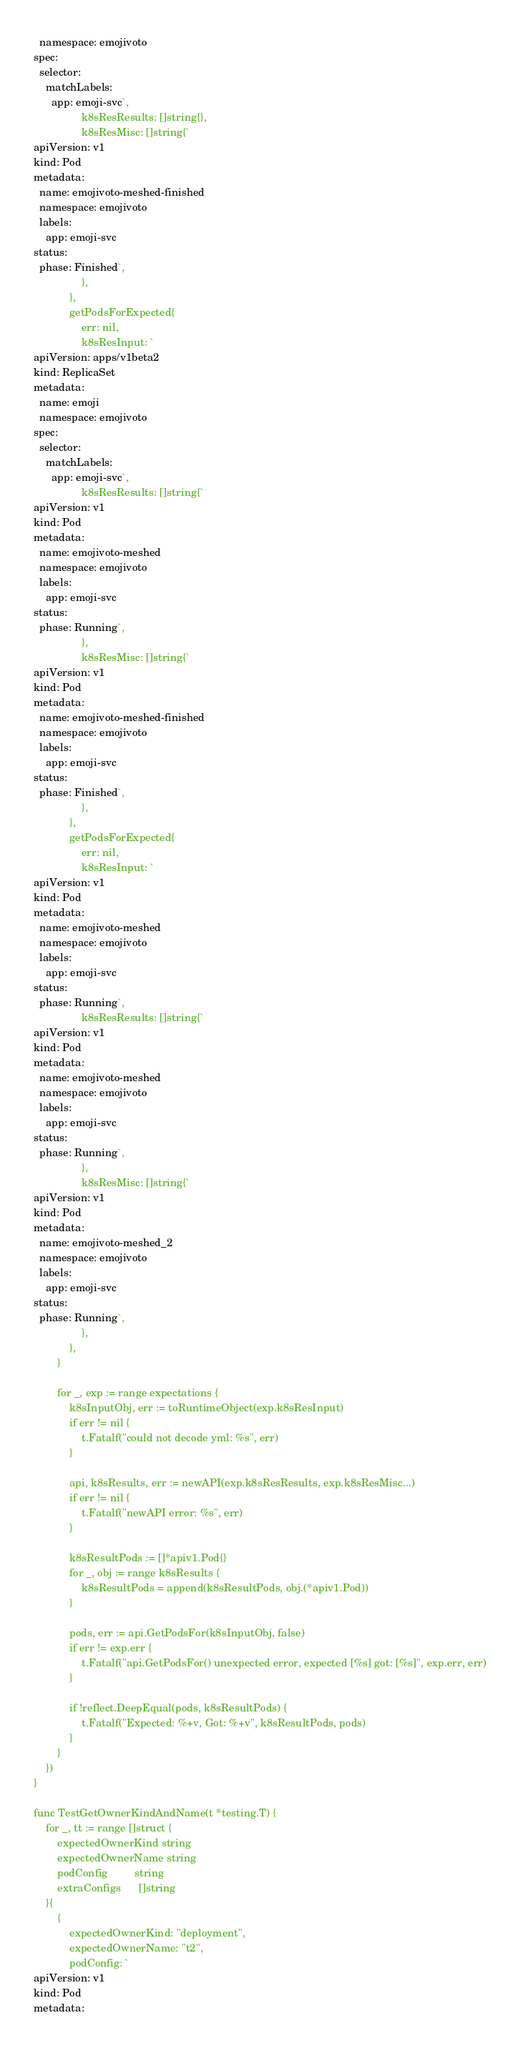Convert code to text. <code><loc_0><loc_0><loc_500><loc_500><_Go_>  namespace: emojivoto
spec:
  selector:
    matchLabels:
      app: emoji-svc`,
				k8sResResults: []string{},
				k8sResMisc: []string{`
apiVersion: v1
kind: Pod
metadata:
  name: emojivoto-meshed-finished
  namespace: emojivoto
  labels:
    app: emoji-svc
status:
  phase: Finished`,
				},
			},
			getPodsForExpected{
				err: nil,
				k8sResInput: `
apiVersion: apps/v1beta2
kind: ReplicaSet
metadata:
  name: emoji
  namespace: emojivoto
spec:
  selector:
    matchLabels:
      app: emoji-svc`,
				k8sResResults: []string{`
apiVersion: v1
kind: Pod
metadata:
  name: emojivoto-meshed
  namespace: emojivoto
  labels:
    app: emoji-svc
status:
  phase: Running`,
				},
				k8sResMisc: []string{`
apiVersion: v1
kind: Pod
metadata:
  name: emojivoto-meshed-finished
  namespace: emojivoto
  labels:
    app: emoji-svc
status:
  phase: Finished`,
				},
			},
			getPodsForExpected{
				err: nil,
				k8sResInput: `
apiVersion: v1
kind: Pod
metadata:
  name: emojivoto-meshed
  namespace: emojivoto
  labels:
    app: emoji-svc
status:
  phase: Running`,
				k8sResResults: []string{`
apiVersion: v1
kind: Pod
metadata:
  name: emojivoto-meshed
  namespace: emojivoto
  labels:
    app: emoji-svc
status:
  phase: Running`,
				},
				k8sResMisc: []string{`
apiVersion: v1
kind: Pod
metadata:
  name: emojivoto-meshed_2
  namespace: emojivoto
  labels:
    app: emoji-svc
status:
  phase: Running`,
				},
			},
		}

		for _, exp := range expectations {
			k8sInputObj, err := toRuntimeObject(exp.k8sResInput)
			if err != nil {
				t.Fatalf("could not decode yml: %s", err)
			}

			api, k8sResults, err := newAPI(exp.k8sResResults, exp.k8sResMisc...)
			if err != nil {
				t.Fatalf("newAPI error: %s", err)
			}

			k8sResultPods := []*apiv1.Pod{}
			for _, obj := range k8sResults {
				k8sResultPods = append(k8sResultPods, obj.(*apiv1.Pod))
			}

			pods, err := api.GetPodsFor(k8sInputObj, false)
			if err != exp.err {
				t.Fatalf("api.GetPodsFor() unexpected error, expected [%s] got: [%s]", exp.err, err)
			}

			if !reflect.DeepEqual(pods, k8sResultPods) {
				t.Fatalf("Expected: %+v, Got: %+v", k8sResultPods, pods)
			}
		}
	})
}

func TestGetOwnerKindAndName(t *testing.T) {
	for _, tt := range []struct {
		expectedOwnerKind string
		expectedOwnerName string
		podConfig         string
		extraConfigs      []string
	}{
		{
			expectedOwnerKind: "deployment",
			expectedOwnerName: "t2",
			podConfig: `
apiVersion: v1
kind: Pod
metadata:</code> 